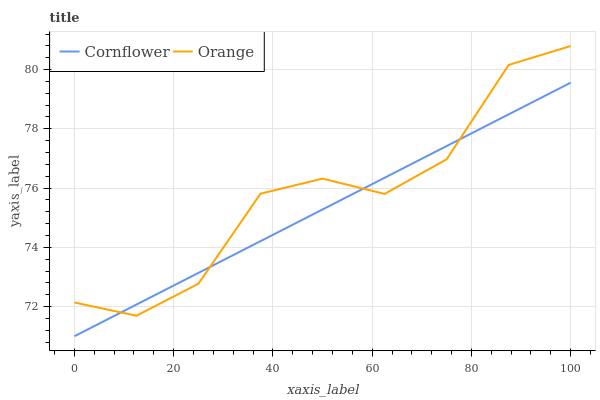Does Cornflower have the minimum area under the curve?
Answer yes or no. Yes. Does Orange have the maximum area under the curve?
Answer yes or no. Yes. Does Cornflower have the maximum area under the curve?
Answer yes or no. No. Is Cornflower the smoothest?
Answer yes or no. Yes. Is Orange the roughest?
Answer yes or no. Yes. Is Cornflower the roughest?
Answer yes or no. No. Does Cornflower have the lowest value?
Answer yes or no. Yes. Does Orange have the highest value?
Answer yes or no. Yes. Does Cornflower have the highest value?
Answer yes or no. No. Does Cornflower intersect Orange?
Answer yes or no. Yes. Is Cornflower less than Orange?
Answer yes or no. No. Is Cornflower greater than Orange?
Answer yes or no. No. 